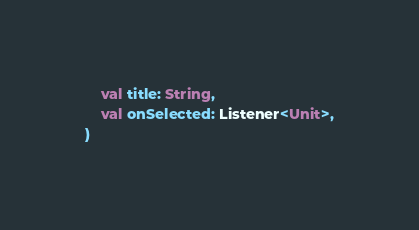<code> <loc_0><loc_0><loc_500><loc_500><_Kotlin_>    val title: String,
    val onSelected: Listener<Unit>,
)
</code> 